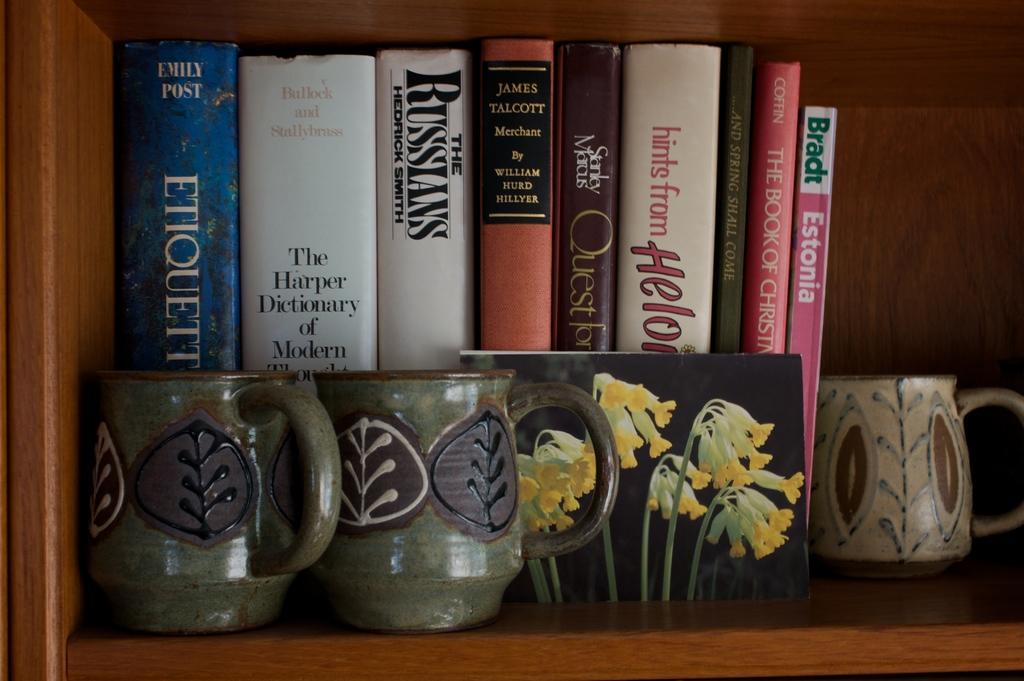Who wrote the book on etiquette?
Give a very brief answer. Emily post. Who wrote estonia?
Keep it short and to the point. Bradt. 